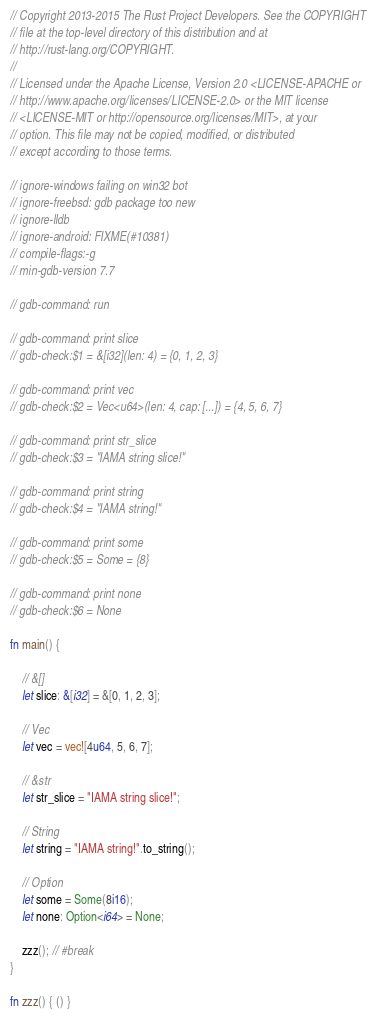<code> <loc_0><loc_0><loc_500><loc_500><_Rust_>// Copyright 2013-2015 The Rust Project Developers. See the COPYRIGHT
// file at the top-level directory of this distribution and at
// http://rust-lang.org/COPYRIGHT.
//
// Licensed under the Apache License, Version 2.0 <LICENSE-APACHE or
// http://www.apache.org/licenses/LICENSE-2.0> or the MIT license
// <LICENSE-MIT or http://opensource.org/licenses/MIT>, at your
// option. This file may not be copied, modified, or distributed
// except according to those terms.

// ignore-windows failing on win32 bot
// ignore-freebsd: gdb package too new
// ignore-lldb
// ignore-android: FIXME(#10381)
// compile-flags:-g
// min-gdb-version 7.7

// gdb-command: run

// gdb-command: print slice
// gdb-check:$1 = &[i32](len: 4) = {0, 1, 2, 3}

// gdb-command: print vec
// gdb-check:$2 = Vec<u64>(len: 4, cap: [...]) = {4, 5, 6, 7}

// gdb-command: print str_slice
// gdb-check:$3 = "IAMA string slice!"

// gdb-command: print string
// gdb-check:$4 = "IAMA string!"

// gdb-command: print some
// gdb-check:$5 = Some = {8}

// gdb-command: print none
// gdb-check:$6 = None

fn main() {

    // &[]
    let slice: &[i32] = &[0, 1, 2, 3];

    // Vec
    let vec = vec![4u64, 5, 6, 7];

    // &str
    let str_slice = "IAMA string slice!";

    // String
    let string = "IAMA string!".to_string();

    // Option
    let some = Some(8i16);
    let none: Option<i64> = None;

    zzz(); // #break
}

fn zzz() { () }
</code> 